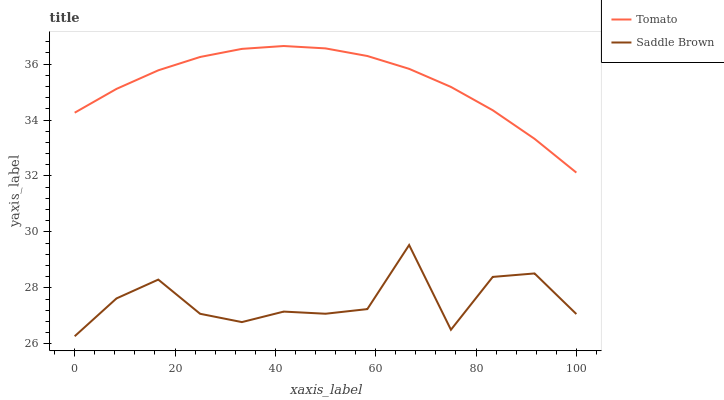Does Saddle Brown have the minimum area under the curve?
Answer yes or no. Yes. Does Tomato have the maximum area under the curve?
Answer yes or no. Yes. Does Saddle Brown have the maximum area under the curve?
Answer yes or no. No. Is Tomato the smoothest?
Answer yes or no. Yes. Is Saddle Brown the roughest?
Answer yes or no. Yes. Is Saddle Brown the smoothest?
Answer yes or no. No. Does Saddle Brown have the lowest value?
Answer yes or no. Yes. Does Tomato have the highest value?
Answer yes or no. Yes. Does Saddle Brown have the highest value?
Answer yes or no. No. Is Saddle Brown less than Tomato?
Answer yes or no. Yes. Is Tomato greater than Saddle Brown?
Answer yes or no. Yes. Does Saddle Brown intersect Tomato?
Answer yes or no. No. 